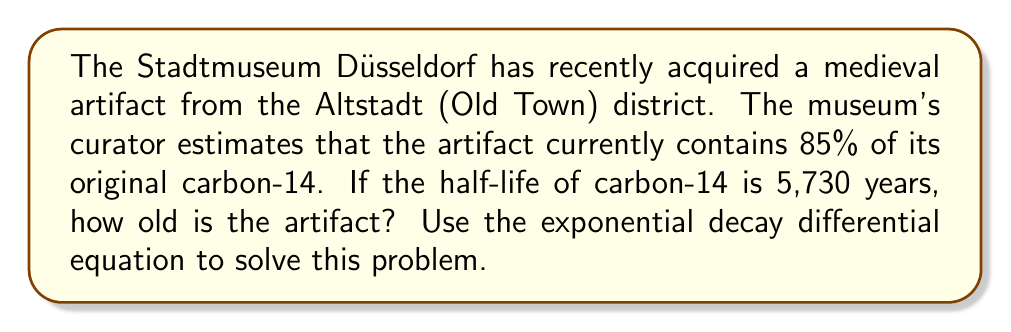Solve this math problem. Let's approach this problem step-by-step using the exponential decay differential equation:

1) The exponential decay equation is:

   $$\frac{dN}{dt} = -kN$$

   where $N$ is the amount of the substance, $t$ is time, and $k$ is the decay constant.

2) The solution to this differential equation is:

   $$N(t) = N_0 e^{-kt}$$

   where $N_0$ is the initial amount.

3) We're given that 85% of the original carbon-14 remains. This means:

   $$\frac{N(t)}{N_0} = 0.85$$

4) Substituting this into our solution:

   $$0.85 = e^{-kt}$$

5) We need to find $k$ using the half-life information. The half-life formula is:

   $$t_{1/2} = \frac{\ln(2)}{k}$$

6) Rearranging to solve for $k$:

   $$k = \frac{\ln(2)}{t_{1/2}} = \frac{\ln(2)}{5730} \approx 1.21 \times 10^{-4}$$

7) Now we can solve for $t$:

   $$0.85 = e^{-(1.21 \times 10^{-4})t}$$

8) Taking the natural log of both sides:

   $$\ln(0.85) = -(1.21 \times 10^{-4})t$$

9) Solving for $t$:

   $$t = -\frac{\ln(0.85)}{1.21 \times 10^{-4}} \approx 1356.2$$

Therefore, the artifact is approximately 1,356 years old.
Answer: The artifact is approximately 1,356 years old. 